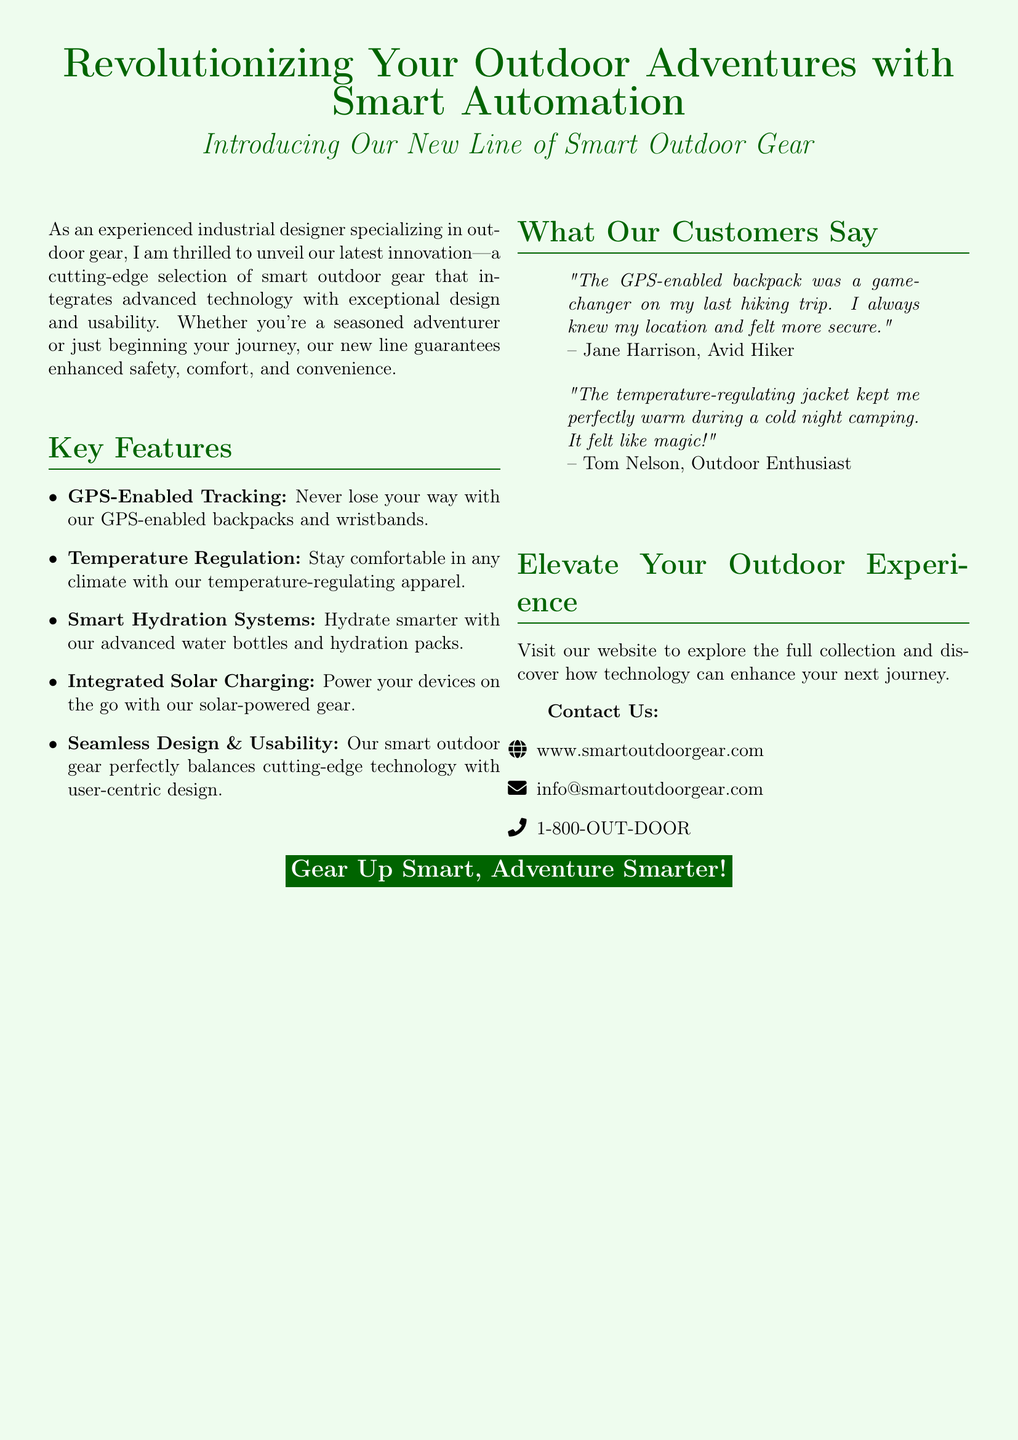What is the title of the advertisement? The title of the advertisement is prominently presented at the top, emphasizing the innovation in outdoor adventures.
Answer: Revolutionizing Your Outdoor Adventures with Smart Automation What is one feature of the smart outdoor gear? The document lists multiple features, with each key point highlighted in the features section.
Answer: GPS-Enabled Tracking Who is quoted as an avid hiker? The document includes customer testimonials with names, linking them to their experiences with the product.
Answer: Jane Harrison What type of technology does the gear include for regulating temperature? The advertisement specifies technology features for enhancing outdoor experiences, particularly in comfort and safety.
Answer: Temperature Regulation What is the website for more information? The document provides contact information at the end, including the website for exploring the full collection of gear.
Answer: www.smartoutdoorgear.com How does the advertisement describe the design of the gear? The features section summarizes the design philosophy, focusing on user experience as a key aspect.
Answer: Seamless Design & Usability Who mentioned that the jacket felt like magic? This particular testimonial includes a customer's feelings about the product, underlining its effectiveness.
Answer: Tom Nelson What type of outdoor gear integrates solar charging? The advertisement explicitly identifies the type of gear that incorporates solar technology.
Answer: Solar-powered gear 